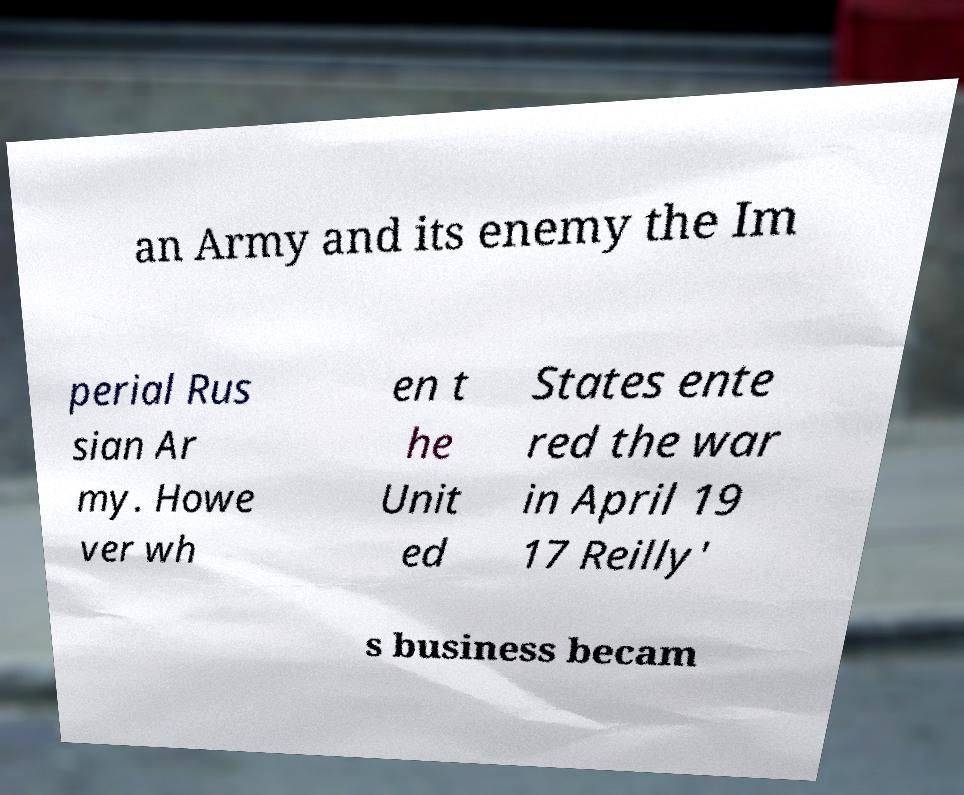What messages or text are displayed in this image? I need them in a readable, typed format. an Army and its enemy the Im perial Rus sian Ar my. Howe ver wh en t he Unit ed States ente red the war in April 19 17 Reilly' s business becam 